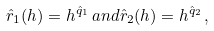<formula> <loc_0><loc_0><loc_500><loc_500>\hat { r } _ { 1 } ( h ) = h ^ { \hat { q } _ { 1 } } \, a n d \hat { r } _ { 2 } ( h ) = h ^ { \hat { q } _ { 2 } } \, ,</formula> 